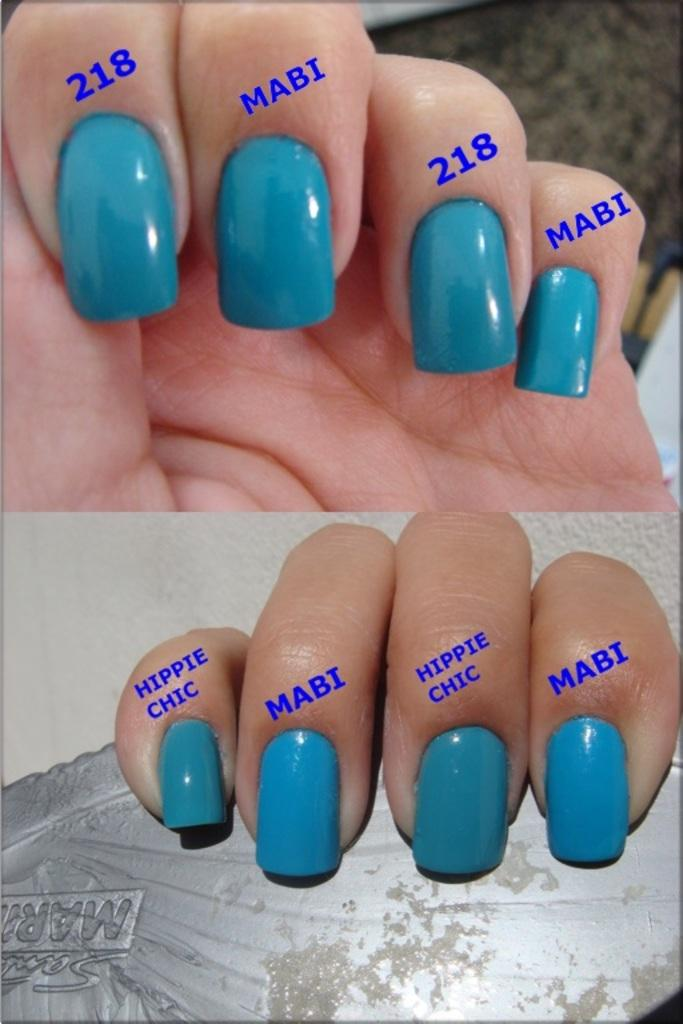<image>
Create a compact narrative representing the image presented. Teal fingernails with names of Hippie Chic, Mabi & 218 